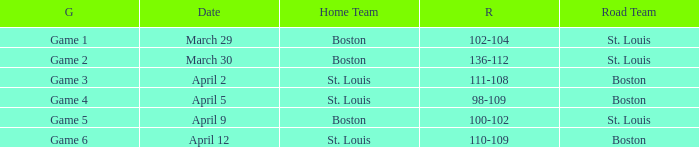What Game had a Result of 136-112? Game 2. 